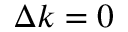<formula> <loc_0><loc_0><loc_500><loc_500>\Delta k = 0</formula> 